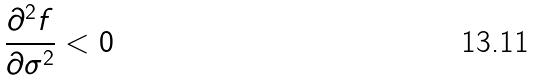Convert formula to latex. <formula><loc_0><loc_0><loc_500><loc_500>\frac { \partial ^ { 2 } f } { \partial \sigma ^ { 2 } } < 0</formula> 